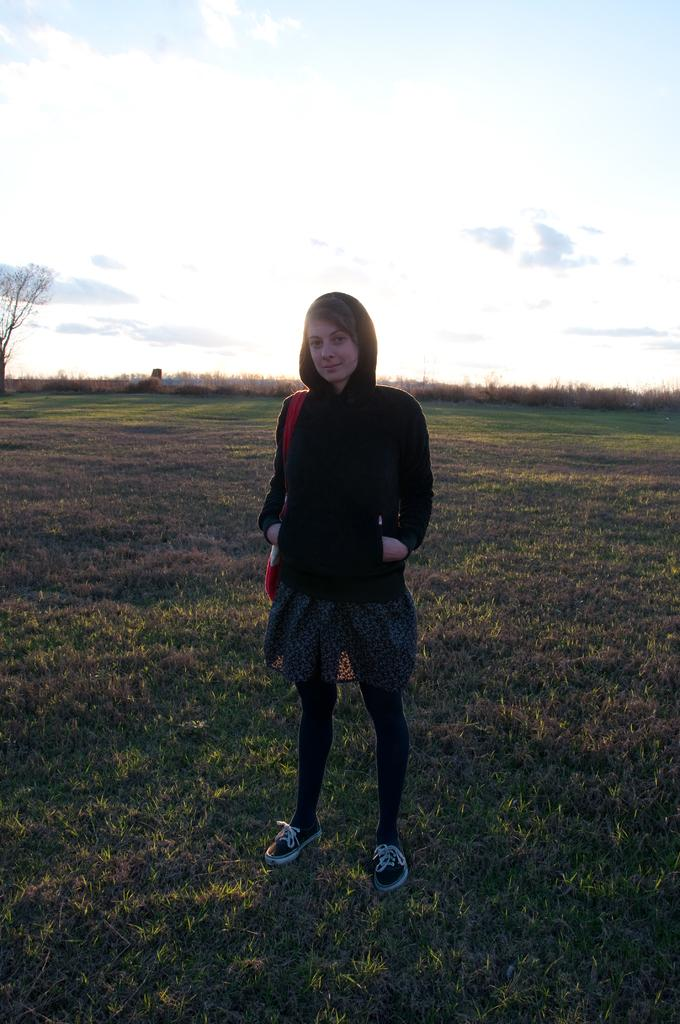Who is the main subject in the picture? There is a woman in the picture. What is the woman doing in the image? The woman is standing. What type of clothing is the woman wearing? The woman is wearing a hoodie. What can be seen in the background of the picture? There is grass and trees in the backdrop of the picture. What instrument is the woman playing in the picture? There is no instrument present in the image; the woman is simply standing. 